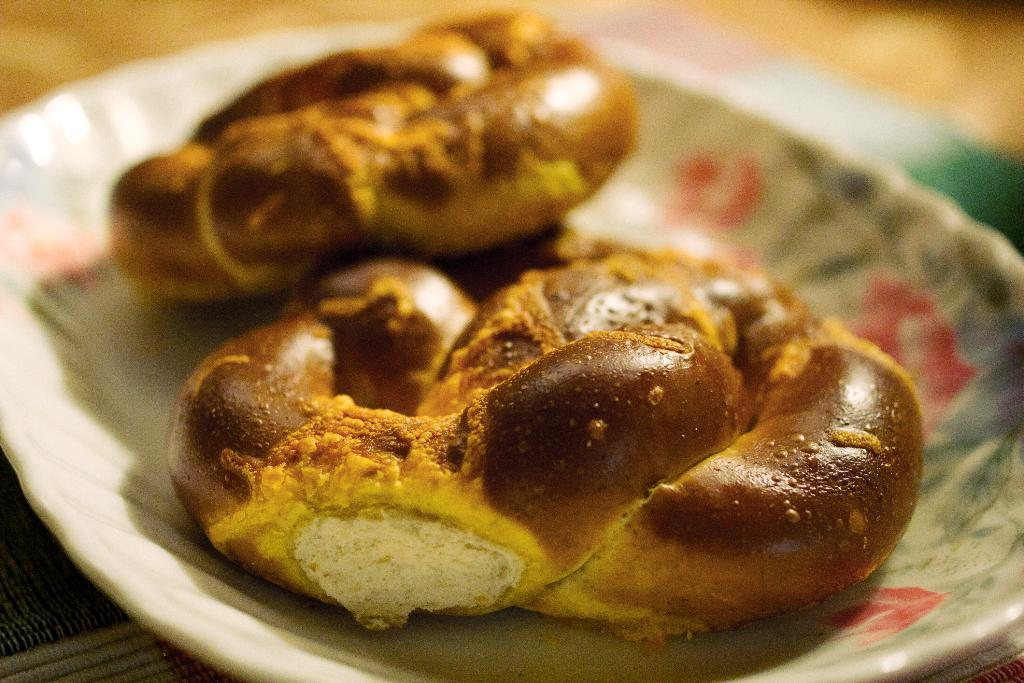What is on the plate that is visible in the image? The plate contains food. Where is the plate located in the image? The plate is placed on a surface. What type of drum is being played in the image? There is no drum present in the image; it only features a plate with food on a surface. 